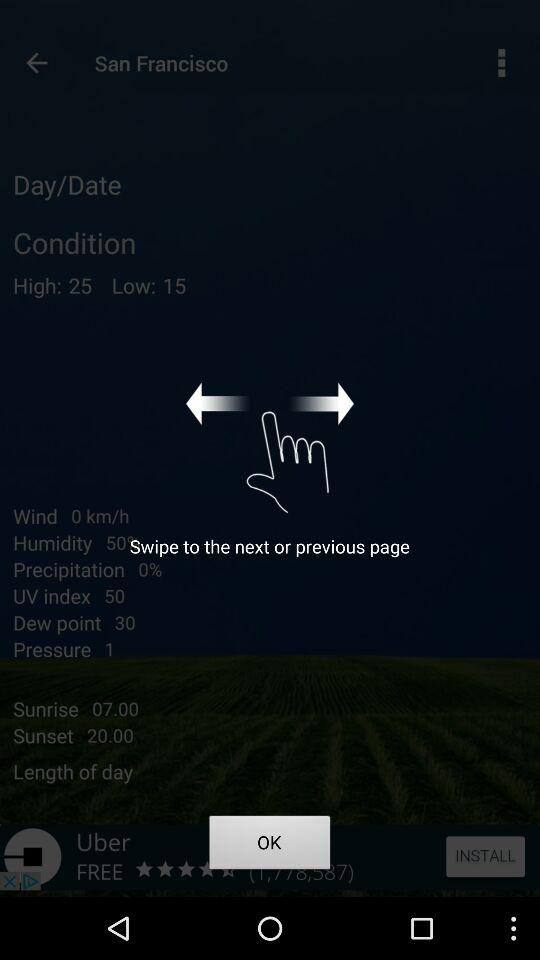How many hours of daylight are there?
Answer the question using a single word or phrase. 13 